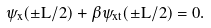Convert formula to latex. <formula><loc_0><loc_0><loc_500><loc_500>\psi _ { x } ( \pm L / 2 ) + \beta \psi _ { x t } ( \pm L / 2 ) = 0 .</formula> 